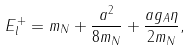<formula> <loc_0><loc_0><loc_500><loc_500>E _ { l } ^ { + } = m _ { N } + \frac { a ^ { 2 } } { 8 m _ { N } } + \frac { a g _ { A } \eta } { 2 m _ { N } } ,</formula> 